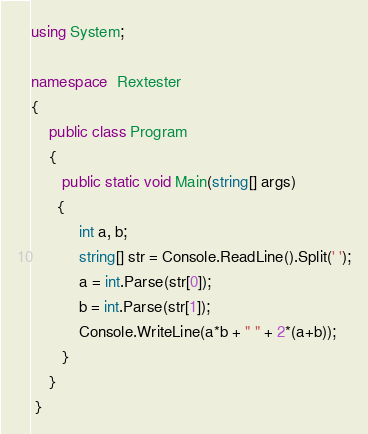Convert code to text. <code><loc_0><loc_0><loc_500><loc_500><_C#_>using System;
 
namespace  Rextester 
{
    public class Program
    {
       public static void Main(string[] args)
      {
           int a, b;
           string[] str = Console.ReadLine().Split(' ');
           a = int.Parse(str[0]);
           b = int.Parse(str[1]);
           Console.WriteLine(a*b + " " + 2*(a+b));
       }
    }
 }
</code> 